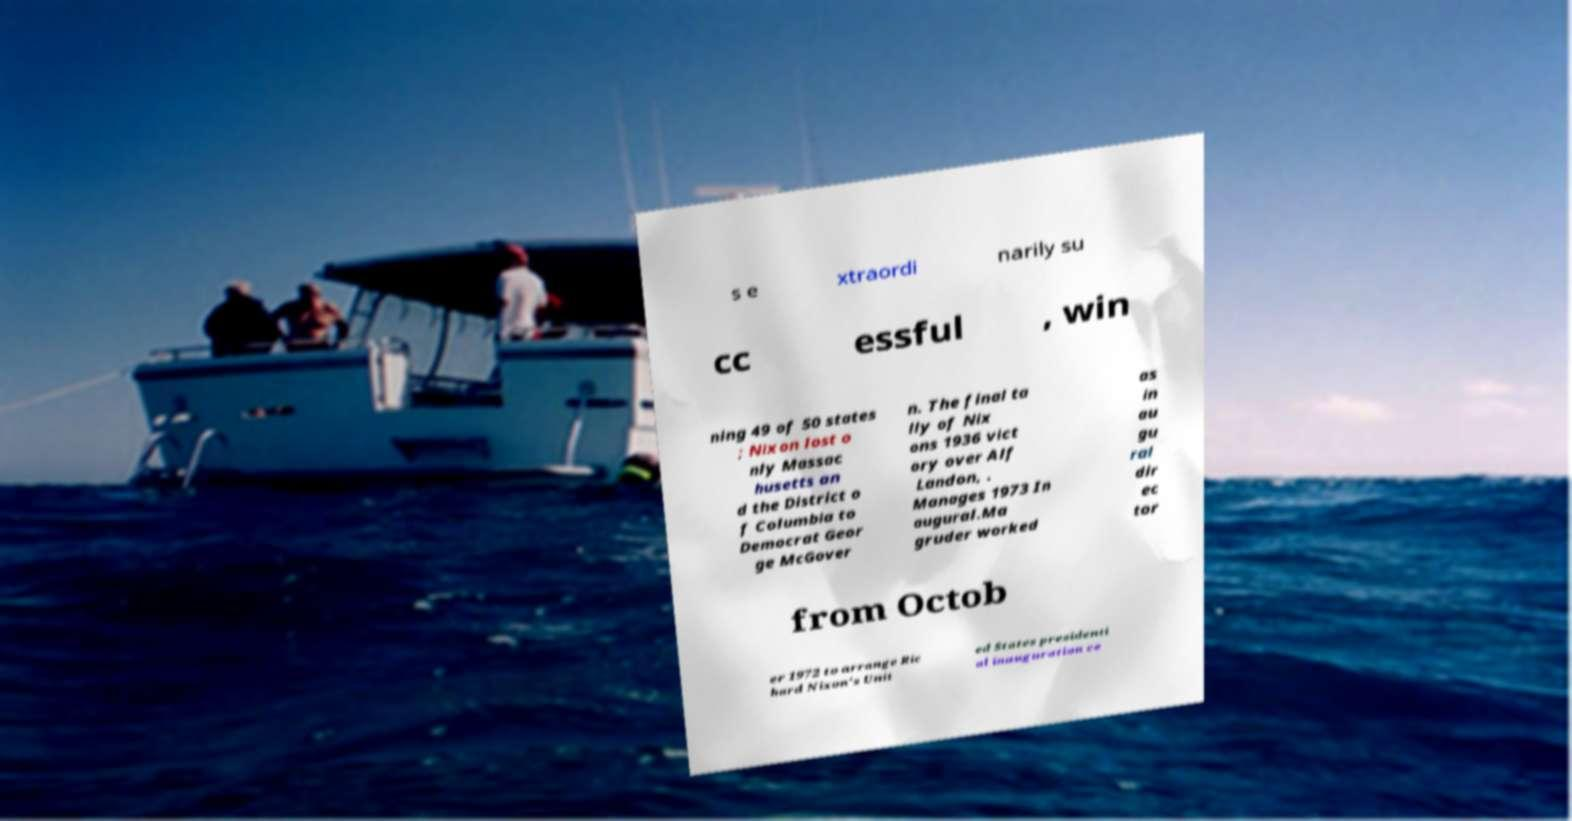Please read and relay the text visible in this image. What does it say? s e xtraordi narily su cc essful , win ning 49 of 50 states ; Nixon lost o nly Massac husetts an d the District o f Columbia to Democrat Geor ge McGover n. The final ta lly of Nix ons 1936 vict ory over Alf Landon, . Manages 1973 In augural.Ma gruder worked as in au gu ral dir ec tor from Octob er 1972 to arrange Ric hard Nixon's Unit ed States presidenti al inauguration ce 